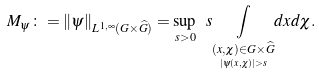Convert formula to latex. <formula><loc_0><loc_0><loc_500><loc_500>M _ { \psi } \colon = \| \psi \| _ { L ^ { 1 , \infty } ( G \times \widehat { G } ) } = \sup _ { s > 0 } \ s \underset { \underset { | \psi ( x , \chi ) | > s } { ( x , \chi ) \in G \times \widehat { G } } } { \int } d x d \chi .</formula> 